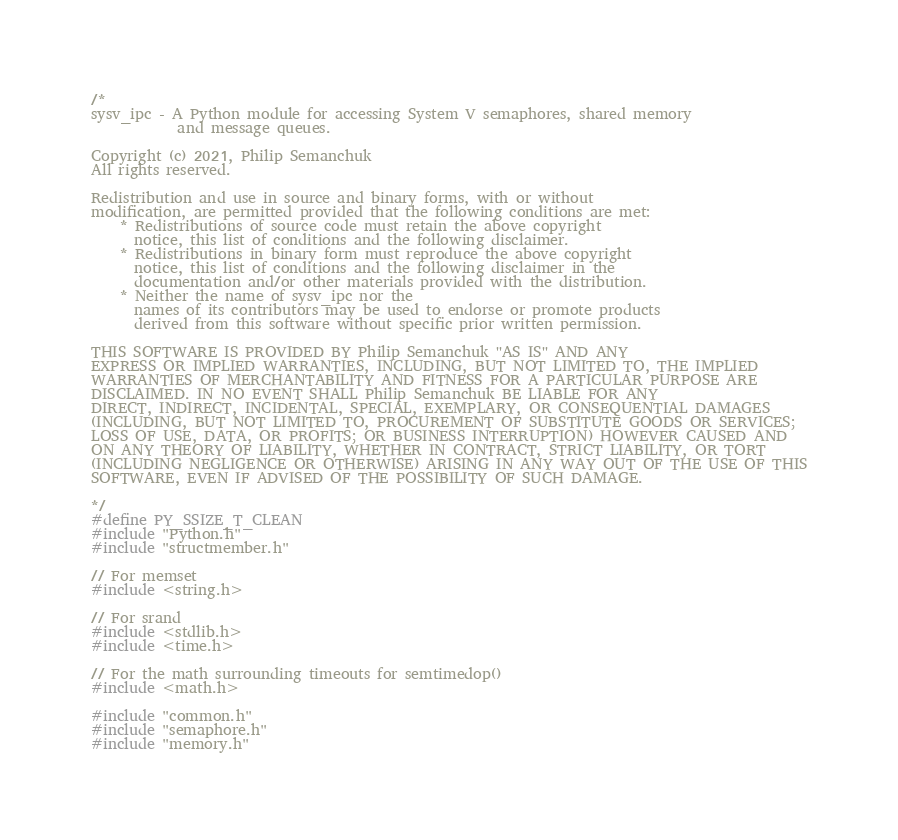<code> <loc_0><loc_0><loc_500><loc_500><_C_>/*
sysv_ipc - A Python module for accessing System V semaphores, shared memory
            and message queues.

Copyright (c) 2021, Philip Semanchuk
All rights reserved.

Redistribution and use in source and binary forms, with or without
modification, are permitted provided that the following conditions are met:
    * Redistributions of source code must retain the above copyright
      notice, this list of conditions and the following disclaimer.
    * Redistributions in binary form must reproduce the above copyright
      notice, this list of conditions and the following disclaimer in the
      documentation and/or other materials provided with the distribution.
    * Neither the name of sysv_ipc nor the
      names of its contributors may be used to endorse or promote products
      derived from this software without specific prior written permission.

THIS SOFTWARE IS PROVIDED BY Philip Semanchuk ''AS IS'' AND ANY
EXPRESS OR IMPLIED WARRANTIES, INCLUDING, BUT NOT LIMITED TO, THE IMPLIED
WARRANTIES OF MERCHANTABILITY AND FITNESS FOR A PARTICULAR PURPOSE ARE
DISCLAIMED. IN NO EVENT SHALL Philip Semanchuk BE LIABLE FOR ANY
DIRECT, INDIRECT, INCIDENTAL, SPECIAL, EXEMPLARY, OR CONSEQUENTIAL DAMAGES
(INCLUDING, BUT NOT LIMITED TO, PROCUREMENT OF SUBSTITUTE GOODS OR SERVICES;
LOSS OF USE, DATA, OR PROFITS; OR BUSINESS INTERRUPTION) HOWEVER CAUSED AND
ON ANY THEORY OF LIABILITY, WHETHER IN CONTRACT, STRICT LIABILITY, OR TORT
(INCLUDING NEGLIGENCE OR OTHERWISE) ARISING IN ANY WAY OUT OF THE USE OF THIS
SOFTWARE, EVEN IF ADVISED OF THE POSSIBILITY OF SUCH DAMAGE.

*/
#define PY_SSIZE_T_CLEAN
#include "Python.h"
#include "structmember.h"

// For memset
#include <string.h>

// For srand
#include <stdlib.h>
#include <time.h>

// For the math surrounding timeouts for semtimedop()
#include <math.h>

#include "common.h"
#include "semaphore.h"
#include "memory.h"</code> 